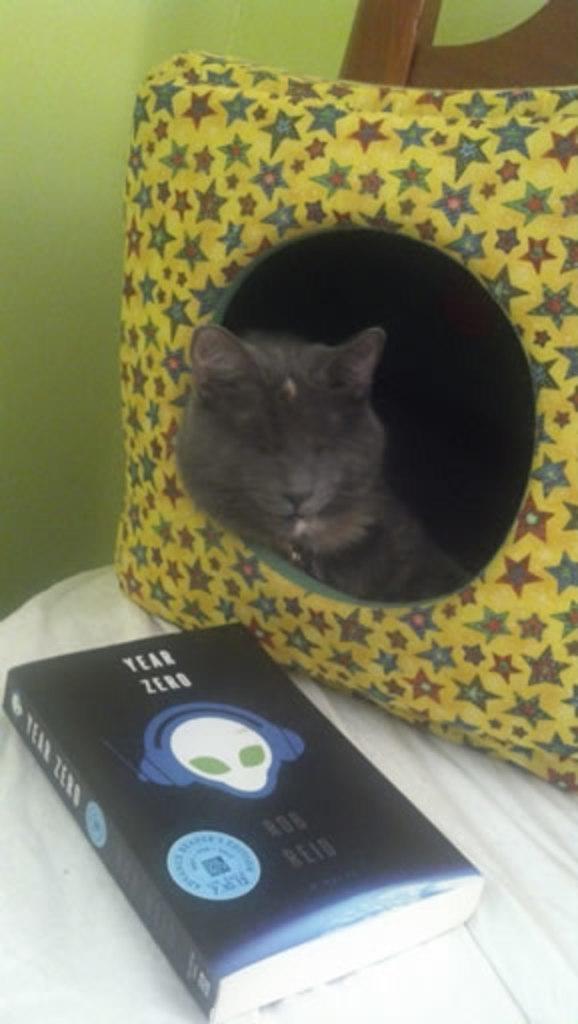How would you summarize this image in a sentence or two? In the image we can see there is a cat sleeping on the pillow and there is a book kept on the chair. 